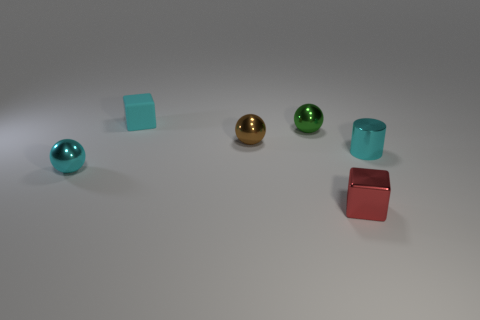Add 1 tiny red cubes. How many objects exist? 7 Subtract all blocks. How many objects are left? 4 Add 3 small brown metallic spheres. How many small brown metallic spheres are left? 4 Add 3 small cyan balls. How many small cyan balls exist? 4 Subtract 0 purple balls. How many objects are left? 6 Subtract all shiny cylinders. Subtract all tiny cyan rubber cubes. How many objects are left? 4 